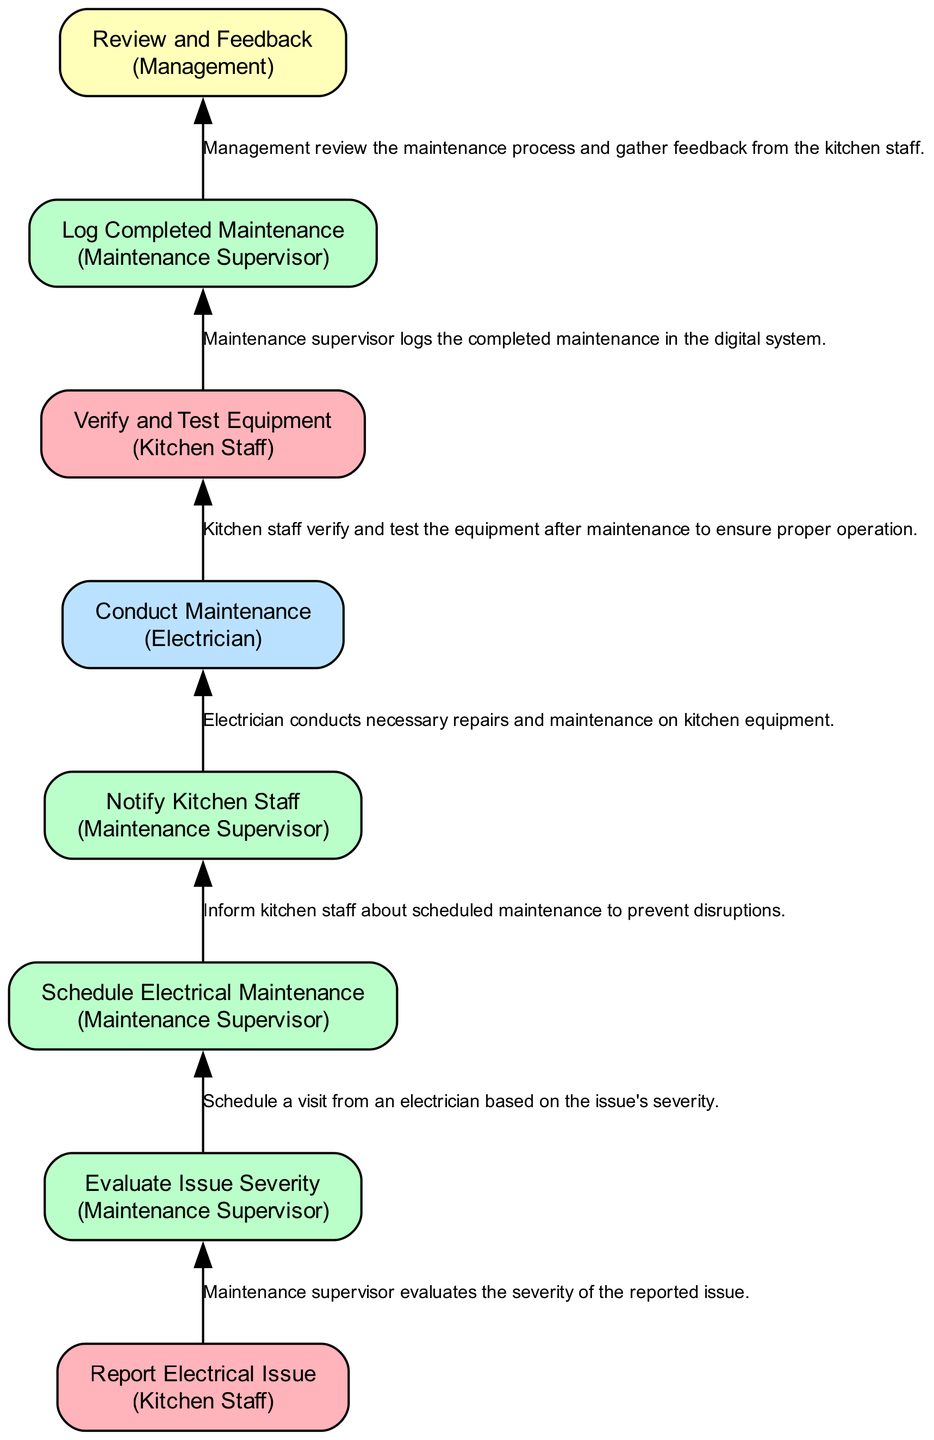What is the first step in the process? The first step is "Report Electrical Issue," where kitchen staff log electrical issues using the digital maintenance logbook.
Answer: Report Electrical Issue Who evaluates the issue severity? The "Evaluate Issue Severity" step is assigned to the Maintenance Supervisor. This step comes after the "Report Electrical Issue" node.
Answer: Maintenance Supervisor How many total tasks are listed in the diagram? The diagram lists eight tasks, including all the steps from reporting an issue to reviewing feedback.
Answer: Eight Which role is responsible for conducting maintenance? The role responsible for conducting maintenance is named "Electrician," assigned to the "Conduct Maintenance" step.
Answer: Electrician What action follows the "Notify Kitchen Staff"? The action that follows "Notify Kitchen Staff" is "Conduct Maintenance," where the electrician performs repairs based on the notification.
Answer: Conduct Maintenance What is the last step in the flowchart? The last step in the flowchart is "Review and Feedback," where management reviews the maintenance process and gathers feedback.
Answer: Review and Feedback How many dependencies does the "Schedule Electrical Maintenance" task have? The "Schedule Electrical Maintenance" task has one dependency, which is "Evaluate Issue Severity."
Answer: One What is the purpose of the "Log Completed Maintenance"? The purpose of "Log Completed Maintenance" is for the Maintenance Supervisor to document the completed maintenance in the digital system.
Answer: Document maintenance Who reviews the maintenance process for feedback? The role that reviews the maintenance process for feedback is the Management, as seen in the "Review and Feedback" step.
Answer: Management 